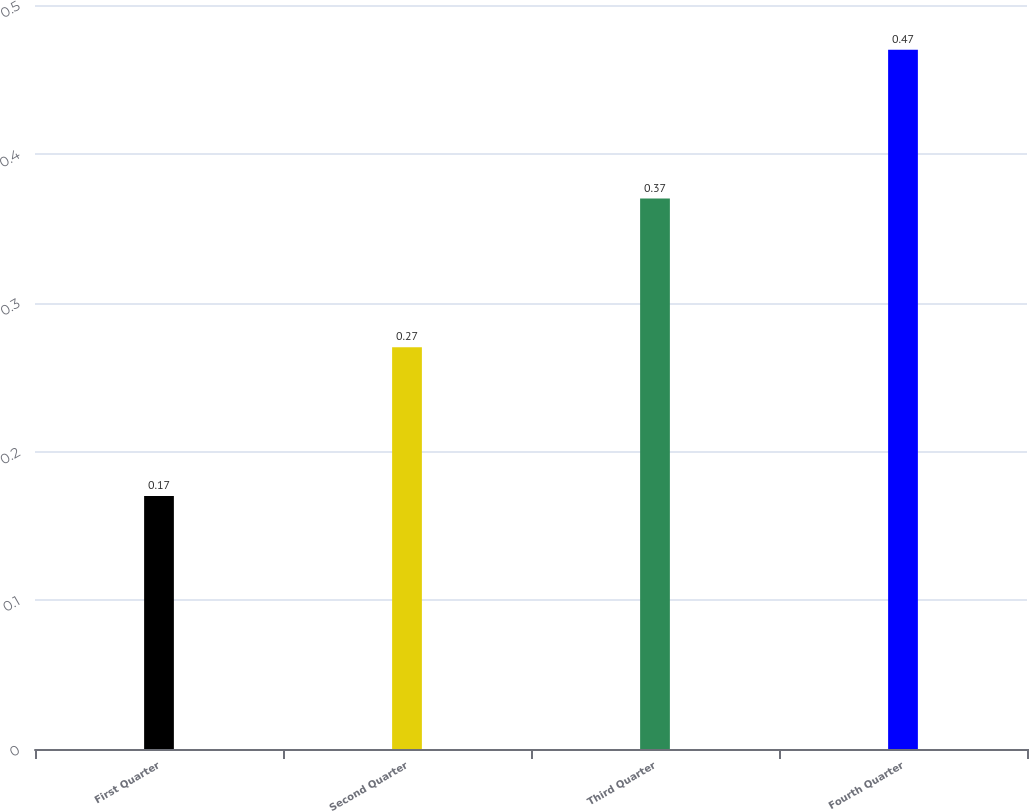Convert chart. <chart><loc_0><loc_0><loc_500><loc_500><bar_chart><fcel>First Quarter<fcel>Second Quarter<fcel>Third Quarter<fcel>Fourth Quarter<nl><fcel>0.17<fcel>0.27<fcel>0.37<fcel>0.47<nl></chart> 